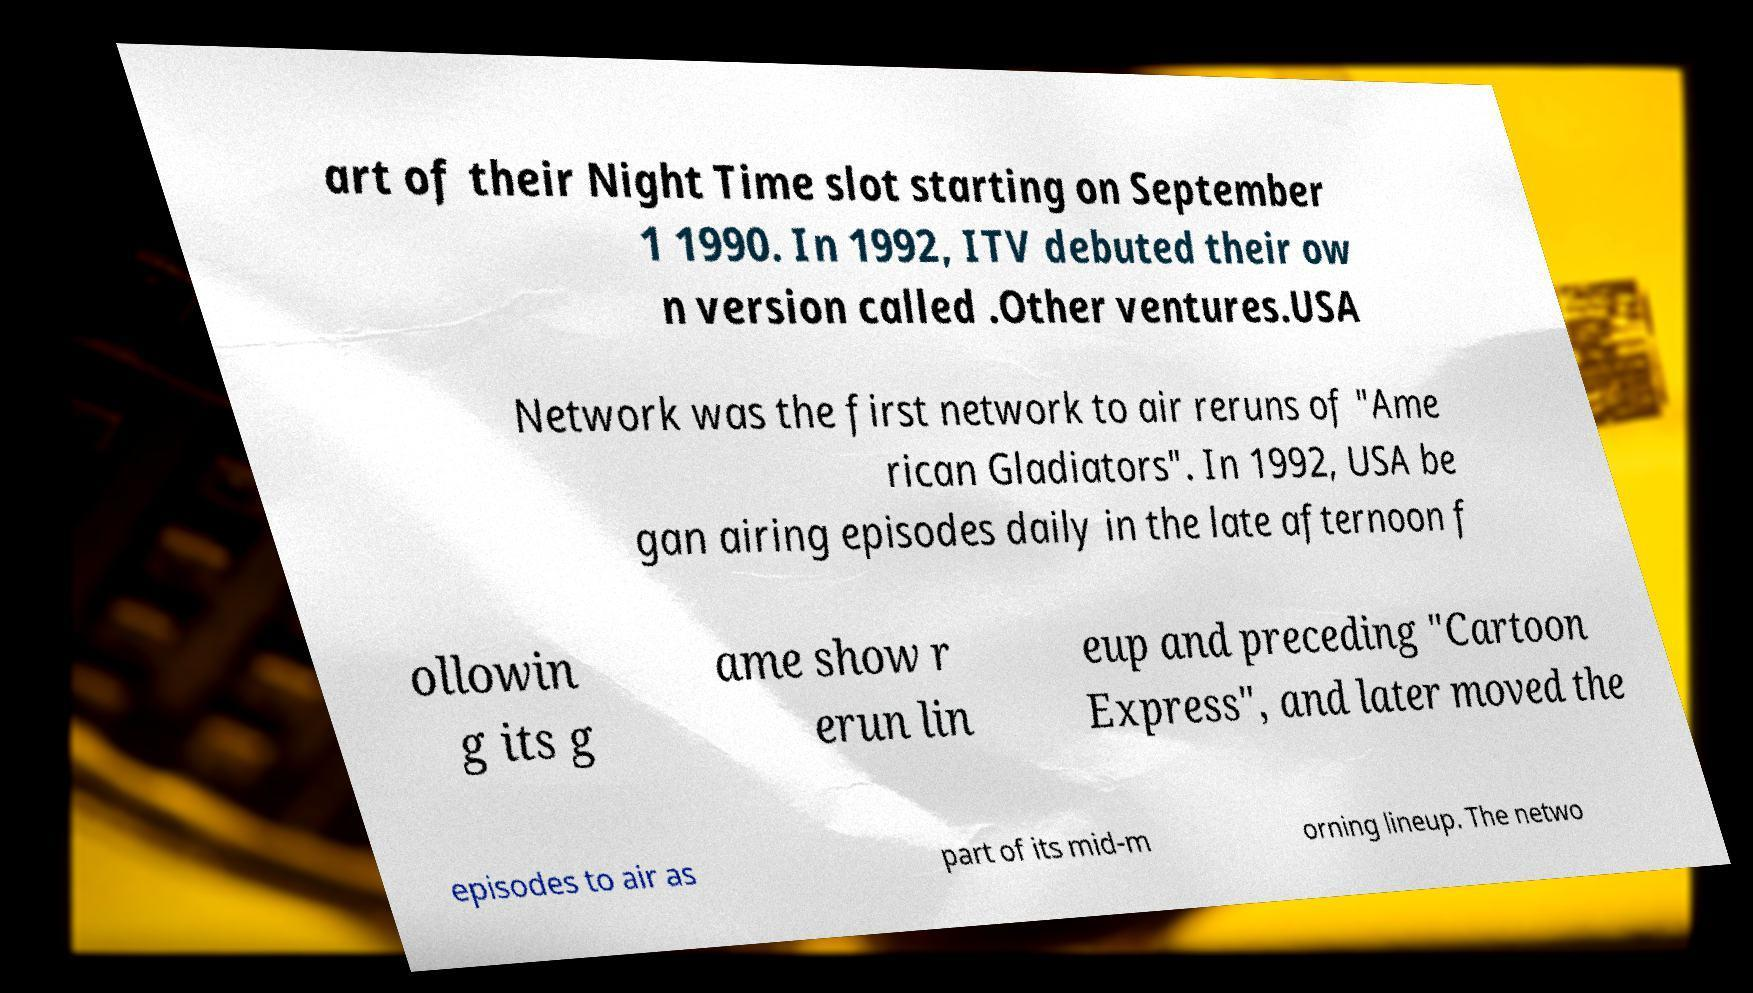There's text embedded in this image that I need extracted. Can you transcribe it verbatim? art of their Night Time slot starting on September 1 1990. In 1992, ITV debuted their ow n version called .Other ventures.USA Network was the first network to air reruns of "Ame rican Gladiators". In 1992, USA be gan airing episodes daily in the late afternoon f ollowin g its g ame show r erun lin eup and preceding "Cartoon Express", and later moved the episodes to air as part of its mid-m orning lineup. The netwo 